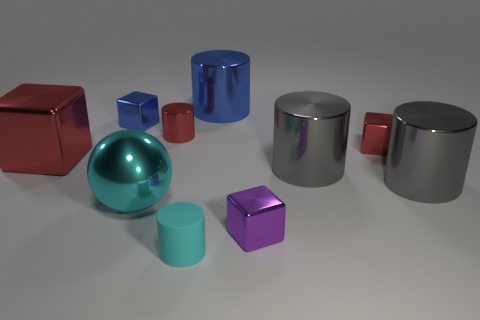What size is the block that is to the right of the purple cube?
Provide a short and direct response. Small. What number of big objects are blue shiny objects or gray metallic cylinders?
Provide a short and direct response. 3. There is a small shiny thing that is right of the cyan metallic sphere and to the left of the matte object; what is its color?
Provide a short and direct response. Red. Is there a gray object that has the same shape as the large red thing?
Your answer should be compact. No. What is the small blue cube made of?
Keep it short and to the point. Metal. There is a large cyan metal object; are there any cyan rubber things behind it?
Offer a terse response. No. Is the shape of the cyan rubber thing the same as the big blue metal object?
Offer a very short reply. Yes. What number of other things are the same size as the sphere?
Give a very brief answer. 4. How many things are either metal cubes that are left of the blue cylinder or big blue metal objects?
Make the answer very short. 3. What is the color of the small rubber thing?
Provide a short and direct response. Cyan. 